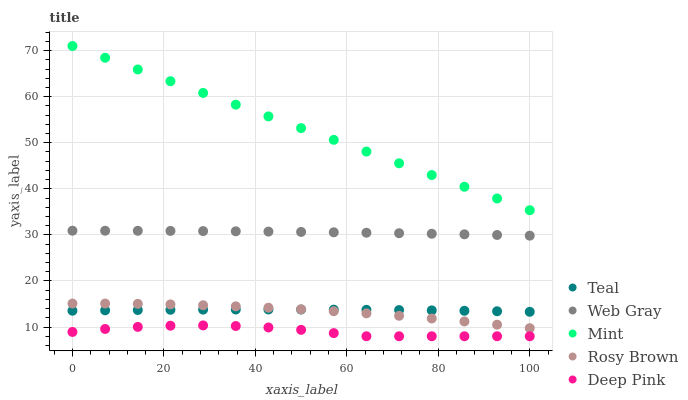Does Deep Pink have the minimum area under the curve?
Answer yes or no. Yes. Does Mint have the maximum area under the curve?
Answer yes or no. Yes. Does Web Gray have the minimum area under the curve?
Answer yes or no. No. Does Web Gray have the maximum area under the curve?
Answer yes or no. No. Is Mint the smoothest?
Answer yes or no. Yes. Is Deep Pink the roughest?
Answer yes or no. Yes. Is Web Gray the smoothest?
Answer yes or no. No. Is Web Gray the roughest?
Answer yes or no. No. Does Deep Pink have the lowest value?
Answer yes or no. Yes. Does Web Gray have the lowest value?
Answer yes or no. No. Does Mint have the highest value?
Answer yes or no. Yes. Does Web Gray have the highest value?
Answer yes or no. No. Is Rosy Brown less than Web Gray?
Answer yes or no. Yes. Is Web Gray greater than Teal?
Answer yes or no. Yes. Does Teal intersect Rosy Brown?
Answer yes or no. Yes. Is Teal less than Rosy Brown?
Answer yes or no. No. Is Teal greater than Rosy Brown?
Answer yes or no. No. Does Rosy Brown intersect Web Gray?
Answer yes or no. No. 